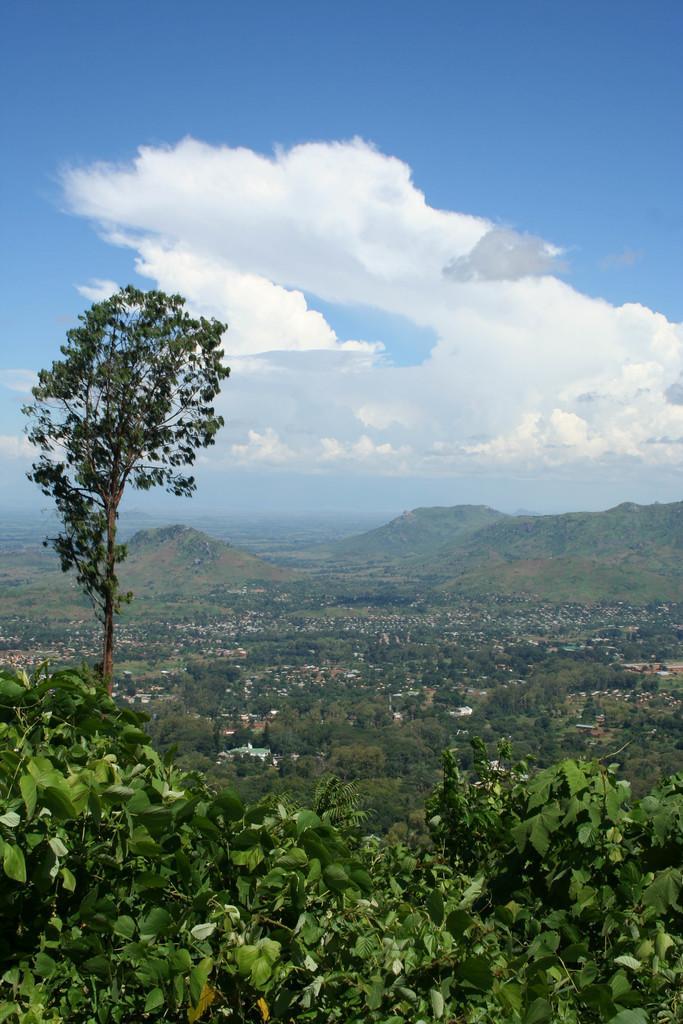Can you describe this image briefly? In this image, we can see plants and tree. In the background, there are so many trees, houses and the sky. 